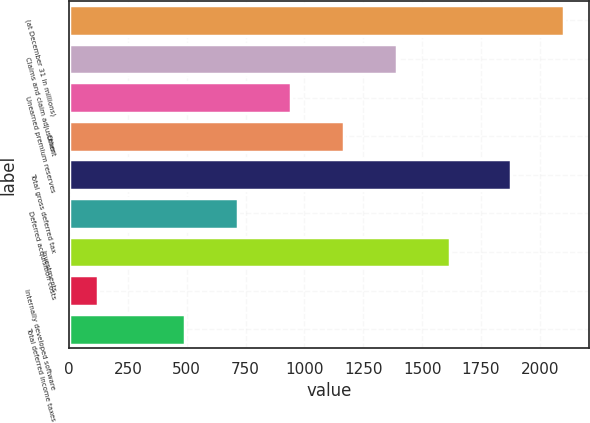Convert chart to OTSL. <chart><loc_0><loc_0><loc_500><loc_500><bar_chart><fcel>(at December 31 in millions)<fcel>Claims and claim adjustment<fcel>Unearned premium reserves<fcel>Other<fcel>Total gross deferred tax<fcel>Deferred acquisition costs<fcel>Investments<fcel>Internally developed software<fcel>Total deferred income taxes<nl><fcel>2102.9<fcel>1392.6<fcel>942.8<fcel>1167.7<fcel>1878<fcel>717.9<fcel>1617.5<fcel>122<fcel>493<nl></chart> 